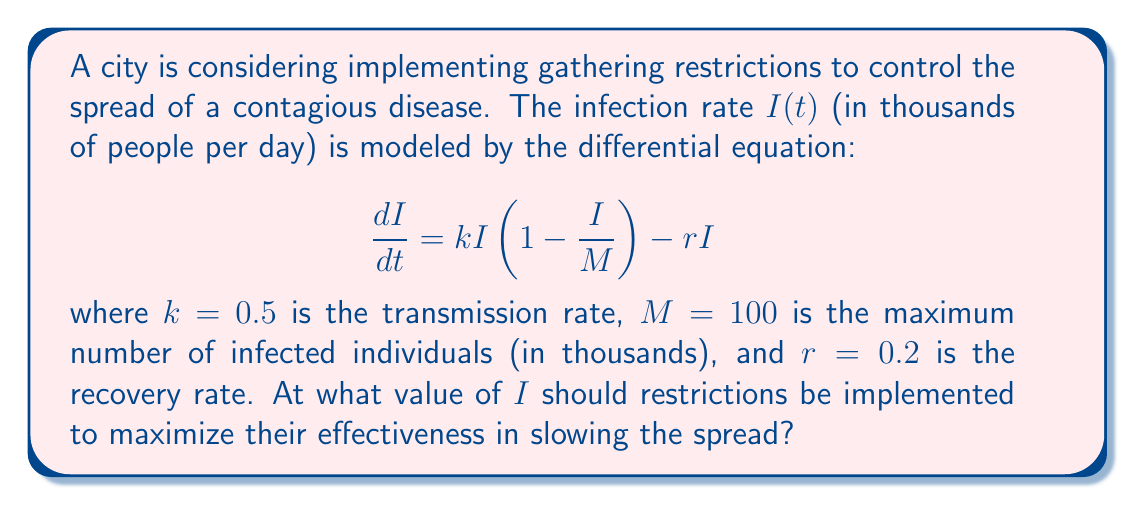Give your solution to this math problem. To determine the optimal timing for implementing restrictions, we need to find the inflection point of the infection curve. This is where the rate of change of new infections is highest, making it the most critical point for intervention.

1) First, we need to find the second derivative of $I$ with respect to $t$:

   $$\frac{d^2I}{dt^2} = \frac{d}{dt}[\frac{dI}{dt}] = \frac{d}{dt}[kI(1-\frac{I}{M}) - rI]$$

2) Using the product rule and chain rule:

   $$\frac{d^2I}{dt^2} = k\frac{dI}{dt}(1-\frac{I}{M}) + kI(-\frac{1}{M}\frac{dI}{dt}) - r\frac{dI}{dt}$$

3) The inflection point occurs when $\frac{d^2I}{dt^2} = 0$. Substituting the original equation for $\frac{dI}{dt}$:

   $$k[kI(1-\frac{I}{M}) - rI](1-\frac{I}{M}) + kI(-\frac{1}{M}[kI(1-\frac{I}{M}) - rI]) - r[kI(1-\frac{I}{M}) - rI] = 0$$

4) This equation can be simplified and solved for $I$. The solution is:

   $$I = \frac{M}{3}(1 + \frac{r}{k})$$

5) Substituting the given values:

   $$I = \frac{100}{3}(1 + \frac{0.2}{0.5}) = 40$$

Therefore, restrictions should be implemented when the number of infected individuals reaches 40,000 (since I is in thousands).
Answer: 40,000 infected individuals 